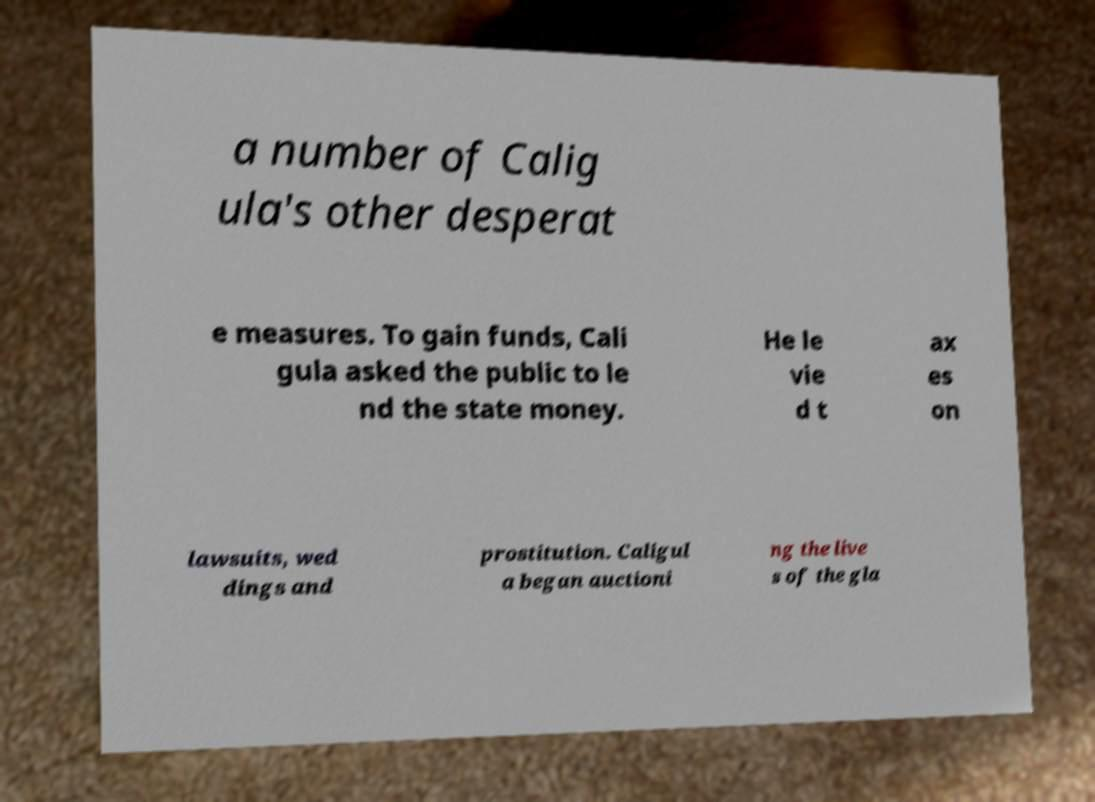There's text embedded in this image that I need extracted. Can you transcribe it verbatim? a number of Calig ula's other desperat e measures. To gain funds, Cali gula asked the public to le nd the state money. He le vie d t ax es on lawsuits, wed dings and prostitution. Caligul a began auctioni ng the live s of the gla 